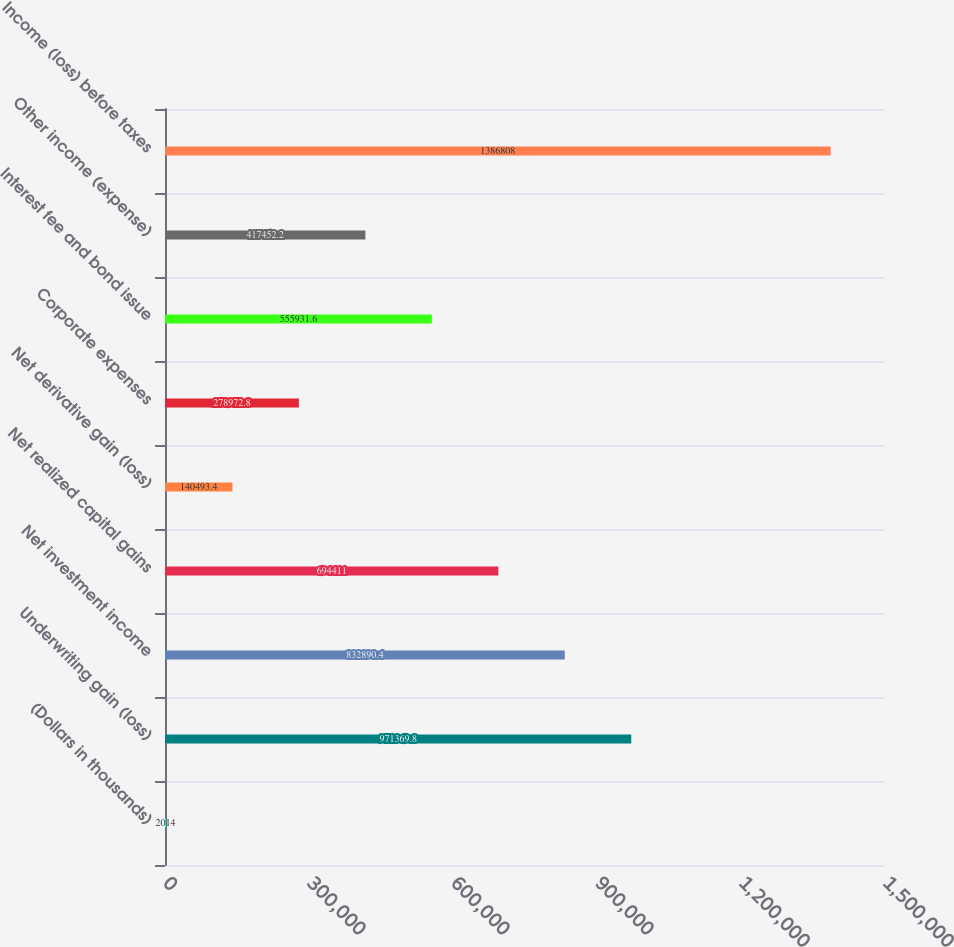Convert chart. <chart><loc_0><loc_0><loc_500><loc_500><bar_chart><fcel>(Dollars in thousands)<fcel>Underwriting gain (loss)<fcel>Net investment income<fcel>Net realized capital gains<fcel>Net derivative gain (loss)<fcel>Corporate expenses<fcel>Interest fee and bond issue<fcel>Other income (expense)<fcel>Income (loss) before taxes<nl><fcel>2014<fcel>971370<fcel>832890<fcel>694411<fcel>140493<fcel>278973<fcel>555932<fcel>417452<fcel>1.38681e+06<nl></chart> 